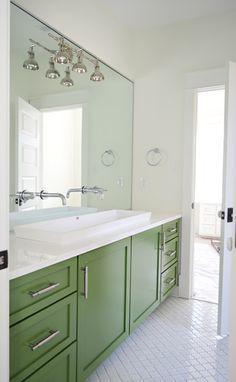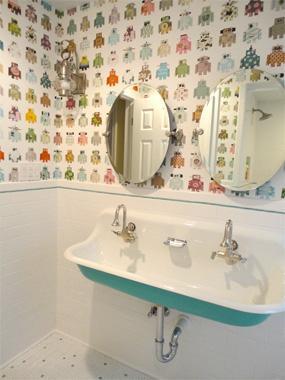The first image is the image on the left, the second image is the image on the right. Analyze the images presented: Is the assertion "porcelain sinks are colored underneath" valid? Answer yes or no. Yes. The first image is the image on the left, the second image is the image on the right. For the images shown, is this caption "One of these images contains two or more footstools, in front of a large sink with multiple faucets." true? Answer yes or no. No. 